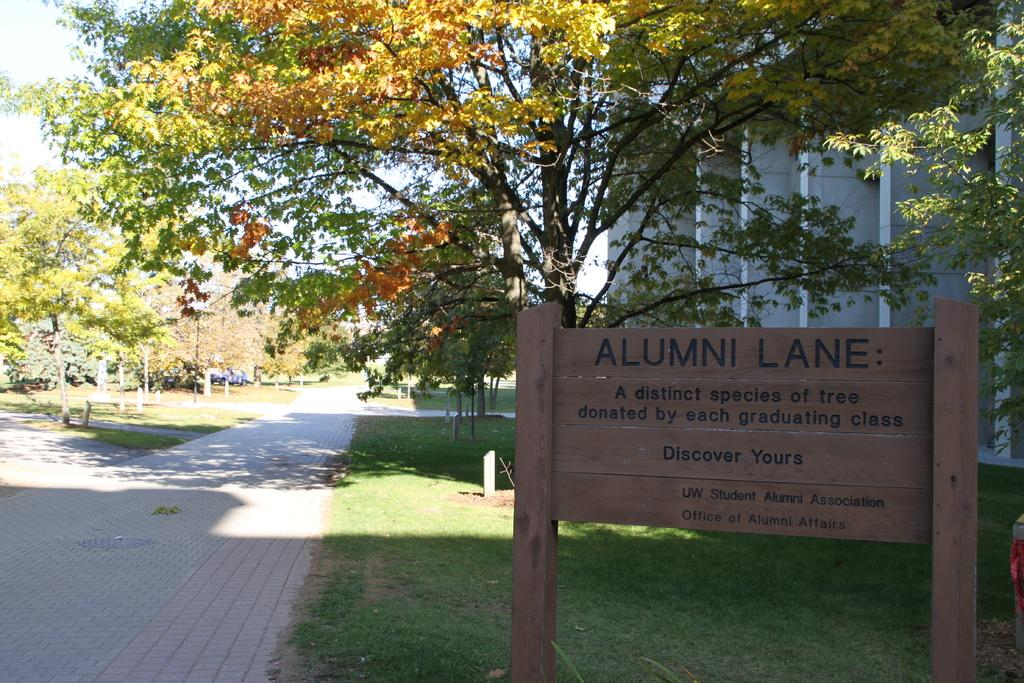What type of structure is visible in the image? There is a building in the image. What type of vegetation can be seen in the image? There are trees in the image. What is written on the board in the image? There is a board with text in the image. What is the ground covered with in the image? There is grass on the ground in the image. What type of vehicle is present in the image? There is a car in the image. What is the weather like in the image? The sky is cloudy in the image. How many boys are playing soccer in the image? There are no boys or soccer game present in the image. What type of school is depicted in the image? There is no school depicted in the image. 